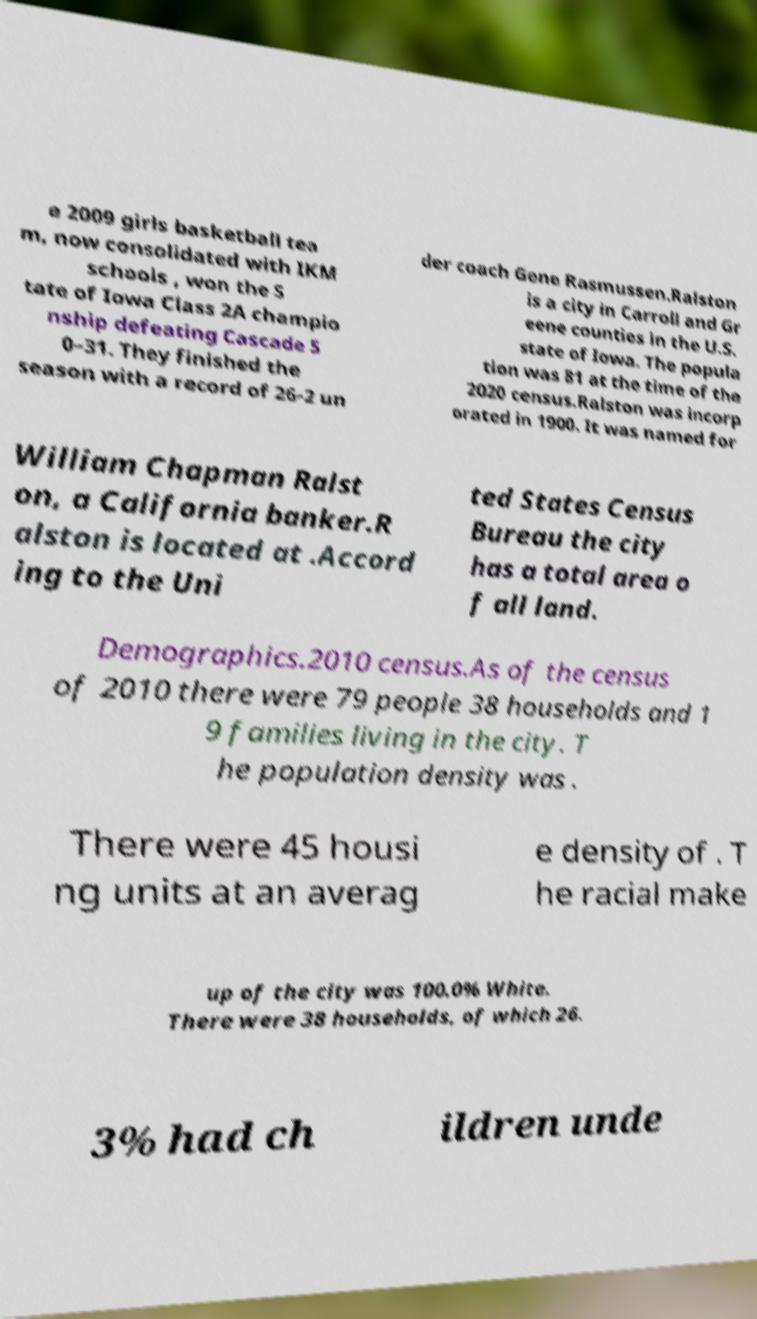Could you extract and type out the text from this image? e 2009 girls basketball tea m, now consolidated with IKM schools , won the S tate of Iowa Class 2A champio nship defeating Cascade 5 0–31. They finished the season with a record of 26-2 un der coach Gene Rasmussen.Ralston is a city in Carroll and Gr eene counties in the U.S. state of Iowa. The popula tion was 81 at the time of the 2020 census.Ralston was incorp orated in 1900. It was named for William Chapman Ralst on, a California banker.R alston is located at .Accord ing to the Uni ted States Census Bureau the city has a total area o f all land. Demographics.2010 census.As of the census of 2010 there were 79 people 38 households and 1 9 families living in the city. T he population density was . There were 45 housi ng units at an averag e density of . T he racial make up of the city was 100.0% White. There were 38 households, of which 26. 3% had ch ildren unde 